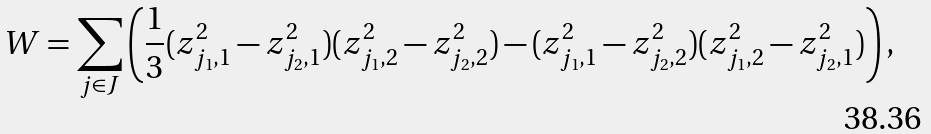<formula> <loc_0><loc_0><loc_500><loc_500>W & = \sum _ { j \in J } \left ( \frac { 1 } { 3 } ( z _ { j _ { 1 } , 1 } ^ { 2 } - z _ { { j _ { 2 } } , 1 } ^ { 2 } ) ( z _ { j _ { 1 } , 2 } ^ { 2 } - z _ { { j _ { 2 } } , 2 } ^ { 2 } ) - ( z _ { j _ { 1 } , 1 } ^ { 2 } - z _ { { j _ { 2 } } , 2 } ^ { 2 } ) ( z _ { j _ { 1 } , 2 } ^ { 2 } - z _ { { j _ { 2 } } , 1 } ^ { 2 } ) \right ) ,</formula> 